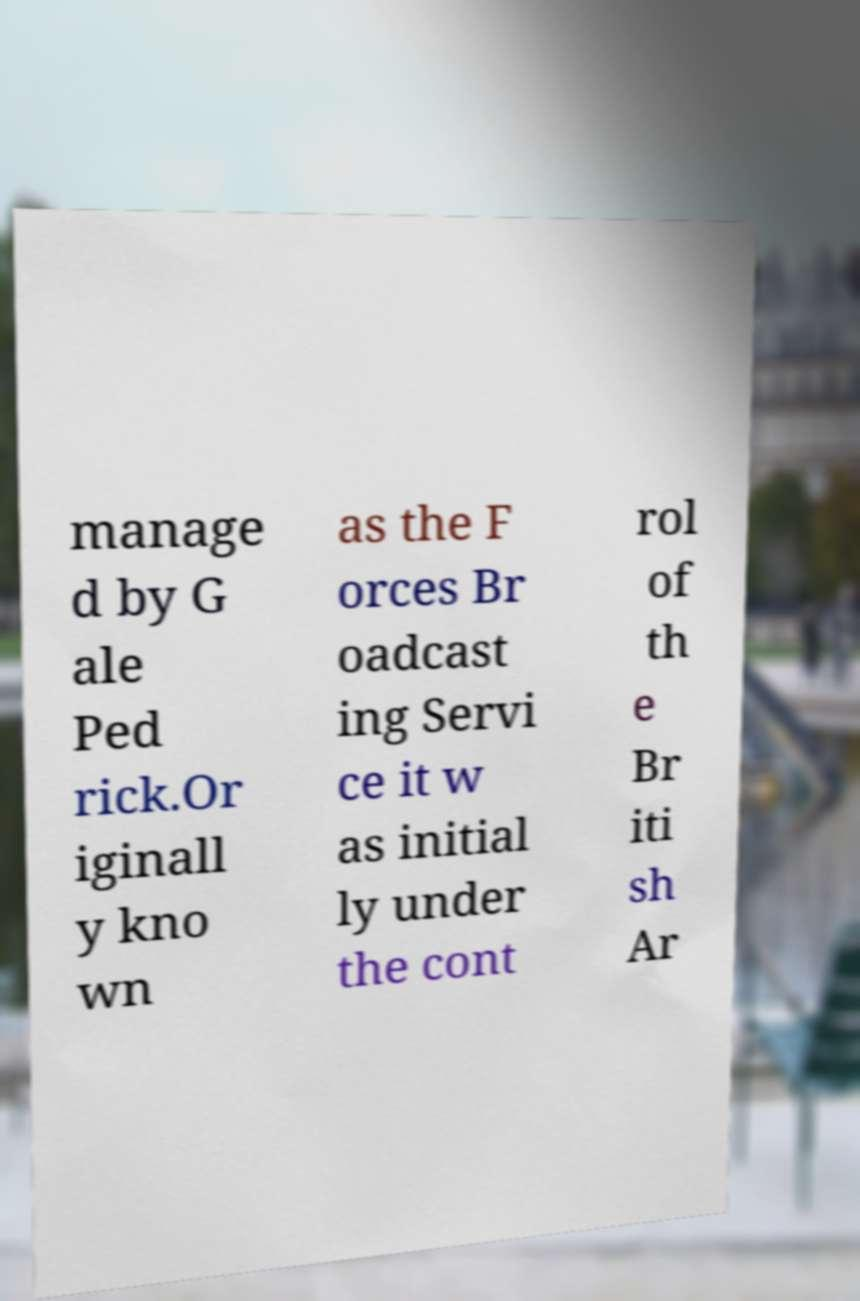Could you extract and type out the text from this image? manage d by G ale Ped rick.Or iginall y kno wn as the F orces Br oadcast ing Servi ce it w as initial ly under the cont rol of th e Br iti sh Ar 